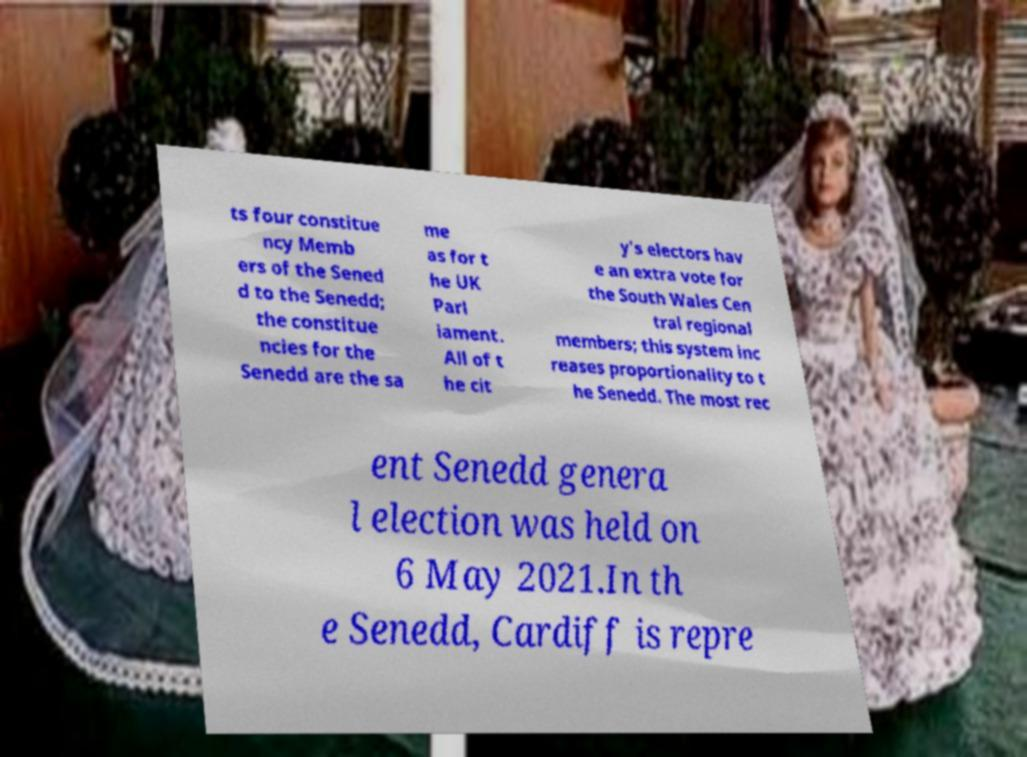What messages or text are displayed in this image? I need them in a readable, typed format. ts four constitue ncy Memb ers of the Sened d to the Senedd; the constitue ncies for the Senedd are the sa me as for t he UK Parl iament. All of t he cit y's electors hav e an extra vote for the South Wales Cen tral regional members; this system inc reases proportionality to t he Senedd. The most rec ent Senedd genera l election was held on 6 May 2021.In th e Senedd, Cardiff is repre 